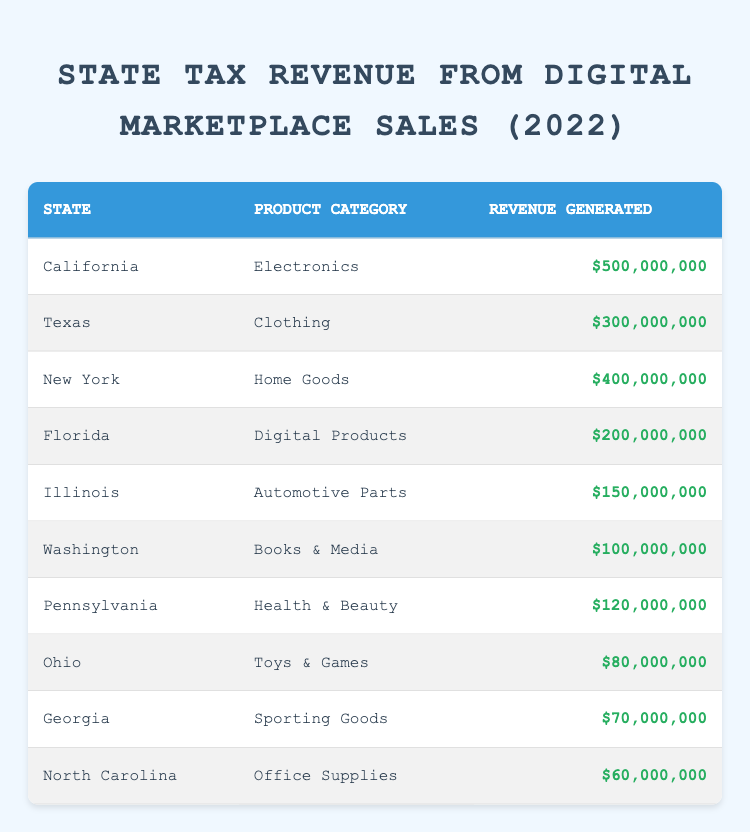What state generated the highest tax revenue from digital marketplace sales? Looking at the revenue generated for each state, California has the highest revenue with five hundred million dollars.
Answer: California What was the total tax revenue generated from digital marketplace sales in Texas and Florida combined? The revenue for Texas is three hundred million and for Florida, it is two hundred million. Adding these gives three hundred million plus two hundred million equals five hundred million.
Answer: Five hundred million Did Washington generate more tax revenue from books and media than Illinois did from automotive parts? Washington generated one hundred million dollars from books and media, while Illinois generated one hundred fifty million dollars from automotive parts. One hundred million is less than one hundred fifty million, so the statement is false.
Answer: No Which product category had the least revenue generation, and how much was it? By checking the revenue generated for all product categories, Ohio with toys and games generated eighty million dollars, which is the lowest amount compared to others.
Answer: Toys and Games, eighty million What is the average tax revenue generated by states for digital marketplace sales in the product categories of health and beauty, automotive parts, and clothing? The revenues are as follows: Pennsylvania generated one hundred twenty million, Illinois generated one hundred fifty million, and Texas generated three hundred million. The total for these is one hundred twenty plus one hundred fifty plus three hundred equals five hundred seventy million. There are three categories, so dividing five hundred seventy million by three gives an average of one hundred ninety million.
Answer: One hundred ninety million 